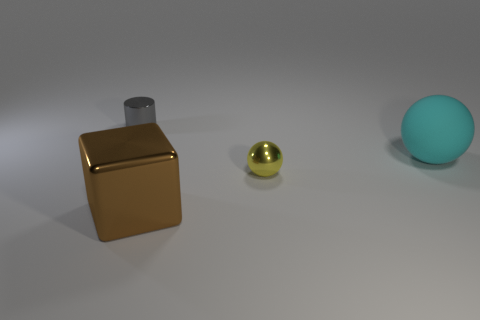What is the color of the small thing to the right of the tiny metallic object that is left of the big brown cube that is left of the yellow shiny ball?
Your answer should be very brief. Yellow. Is the size of the brown metallic cube the same as the yellow metallic ball?
Ensure brevity in your answer.  No. Is there anything else that is the same shape as the matte object?
Your answer should be very brief. Yes. What number of things are tiny objects behind the cyan ball or blue cylinders?
Ensure brevity in your answer.  1. Is the small yellow object the same shape as the gray thing?
Provide a short and direct response. No. How many other things are the same size as the cyan sphere?
Provide a short and direct response. 1. What color is the large cube?
Provide a short and direct response. Brown. How many small things are either yellow balls or metal cylinders?
Provide a short and direct response. 2. Does the ball that is to the left of the cyan ball have the same size as the gray metal cylinder on the left side of the large metallic object?
Your response must be concise. Yes. What is the size of the cyan rubber thing that is the same shape as the small yellow metal object?
Offer a terse response. Large. 